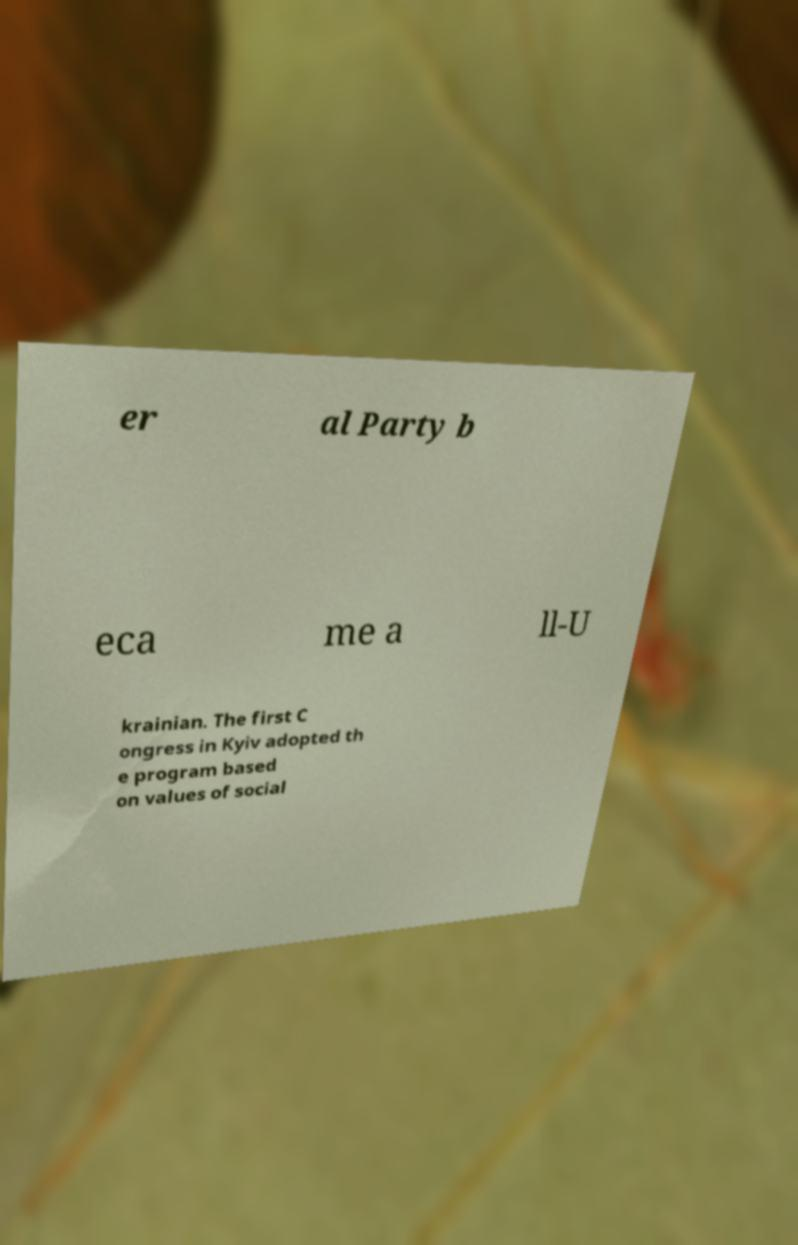What messages or text are displayed in this image? I need them in a readable, typed format. er al Party b eca me a ll-U krainian. The first C ongress in Kyiv adopted th e program based on values of social 